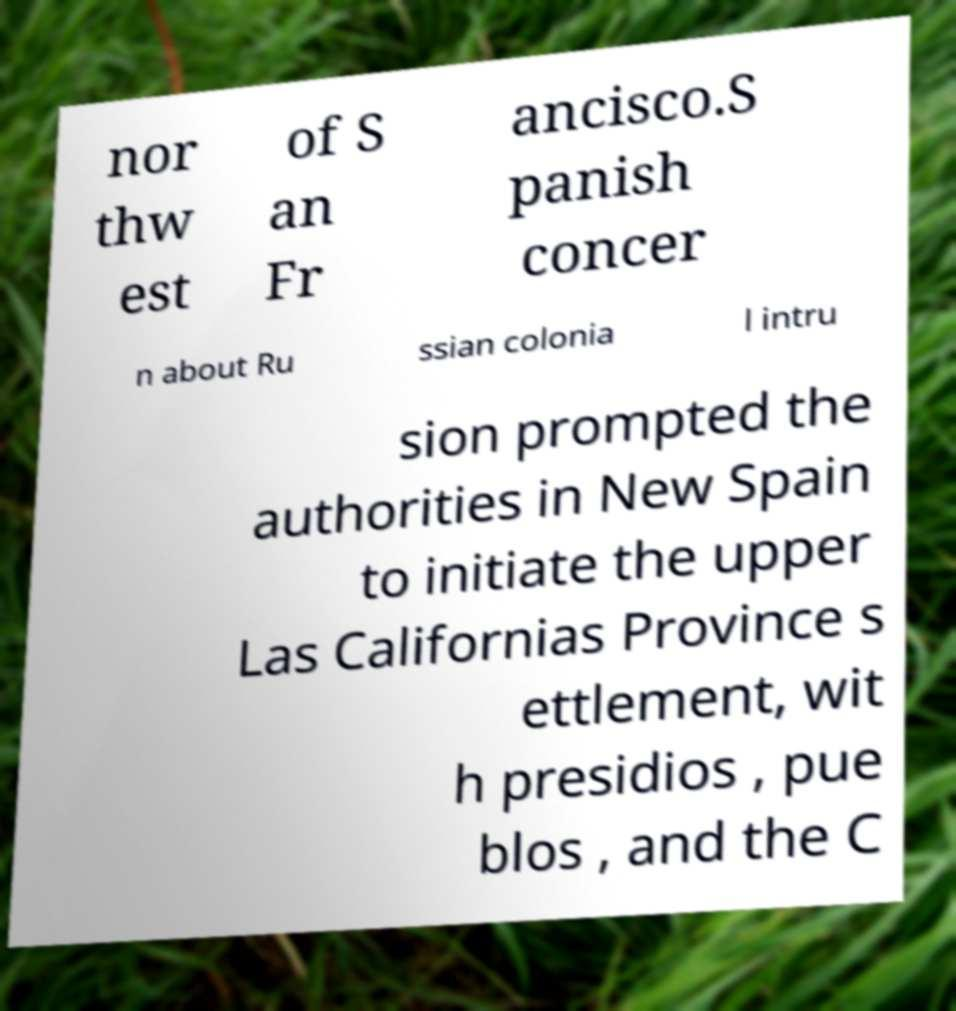I need the written content from this picture converted into text. Can you do that? nor thw est of S an Fr ancisco.S panish concer n about Ru ssian colonia l intru sion prompted the authorities in New Spain to initiate the upper Las Californias Province s ettlement, wit h presidios , pue blos , and the C 